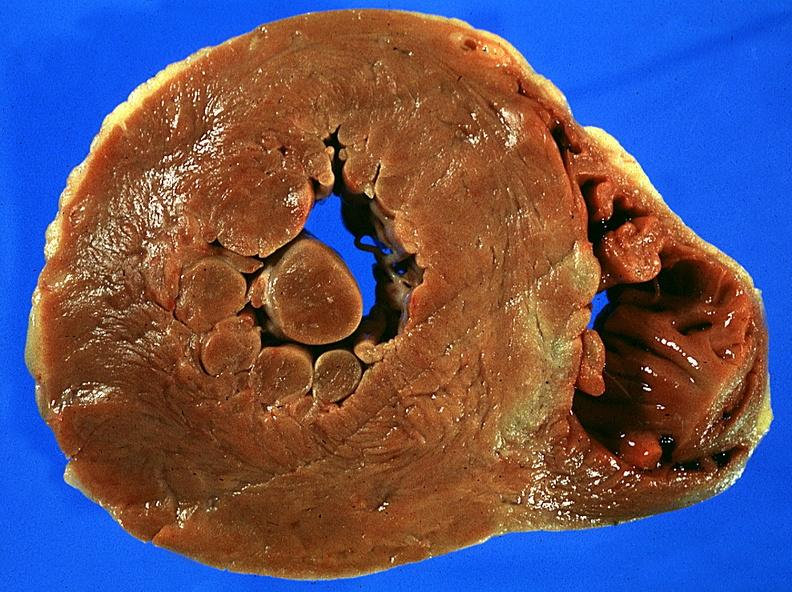s cardiovascular present?
Answer the question using a single word or phrase. Yes 